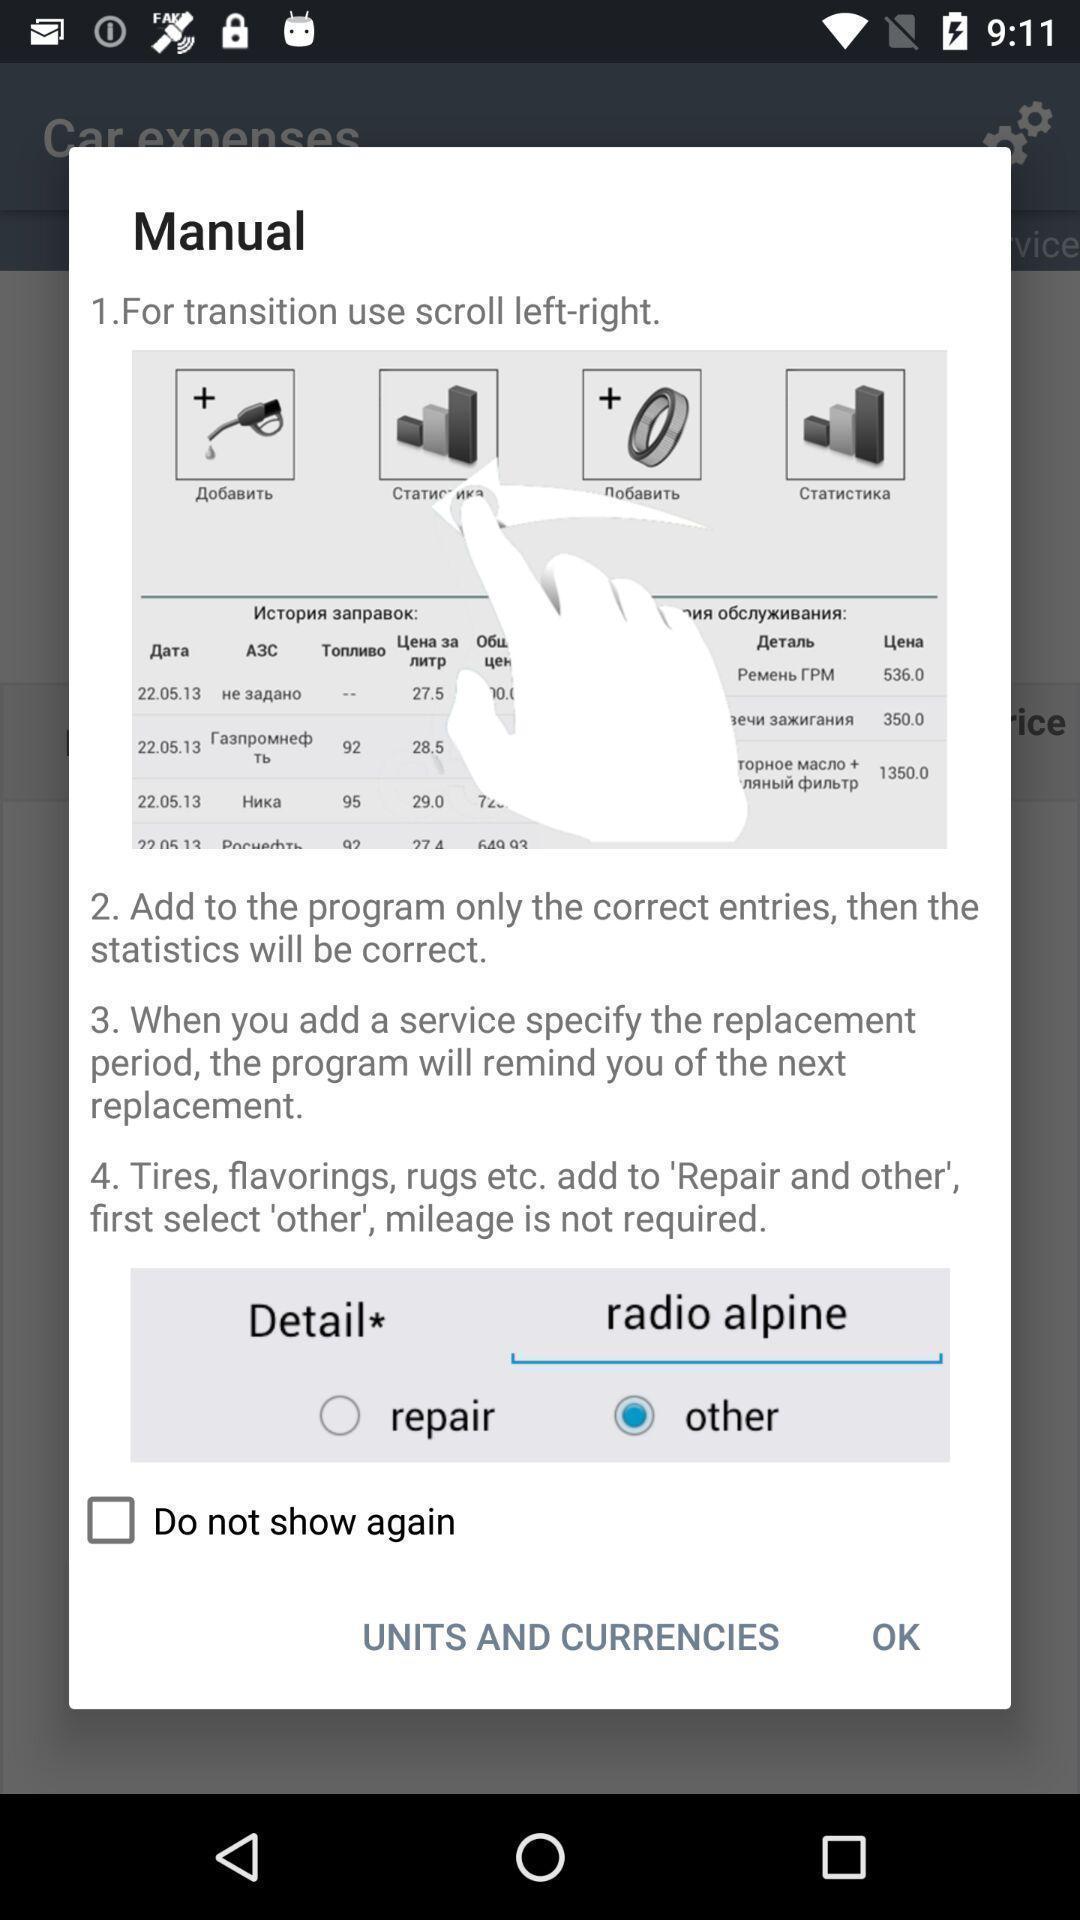Tell me about the visual elements in this screen capture. Pop up showing manual information. 